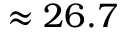<formula> <loc_0><loc_0><loc_500><loc_500>\approx 2 6 . 7</formula> 